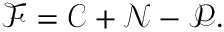Convert formula to latex. <formula><loc_0><loc_0><loc_500><loc_500>\mathcal { F } = \mathcal { C } + \mathcal { N } - \mathcal { P } .</formula> 